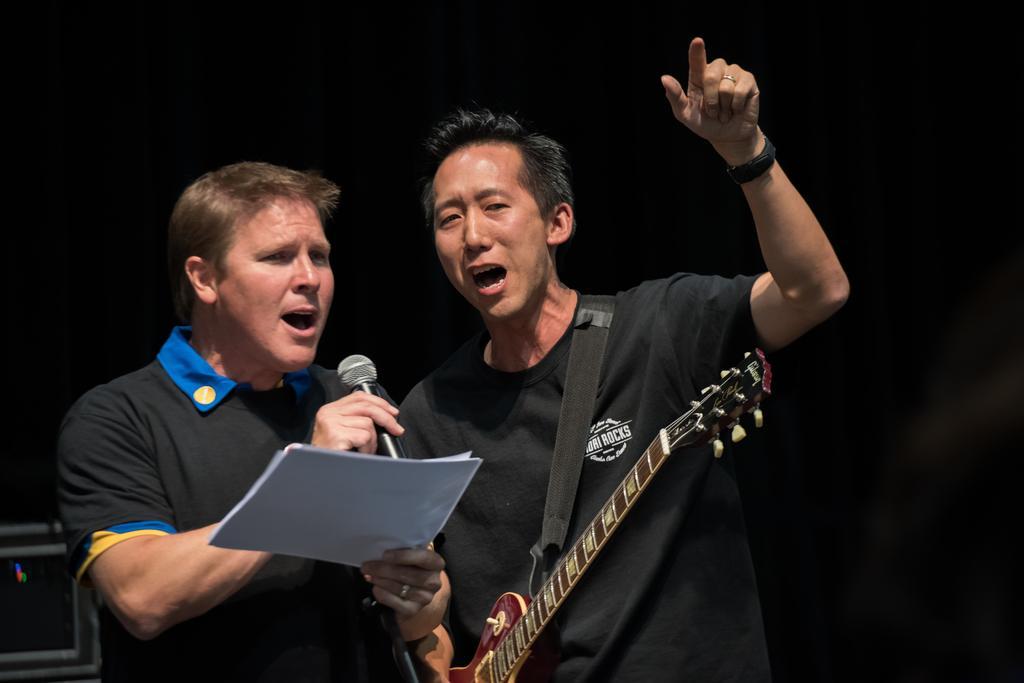Please provide a concise description of this image. In the image we can see there are people who are holding guitar in their hand and a mic. 